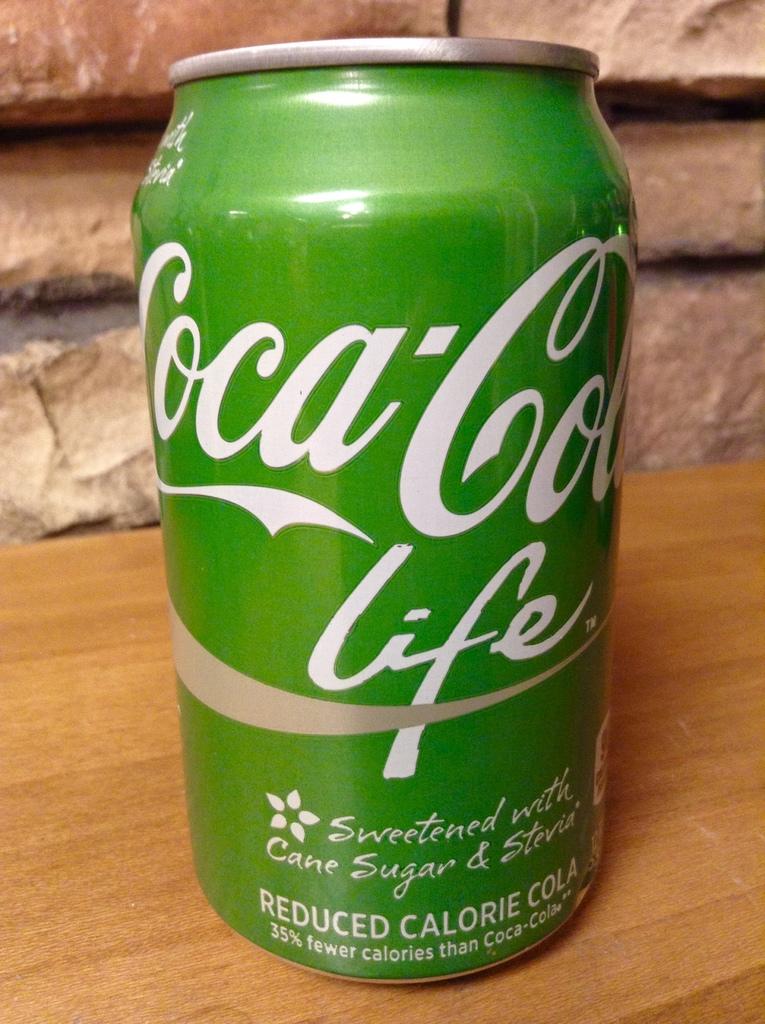Which version of coca-cola is pictured?
Offer a terse response. Life. 